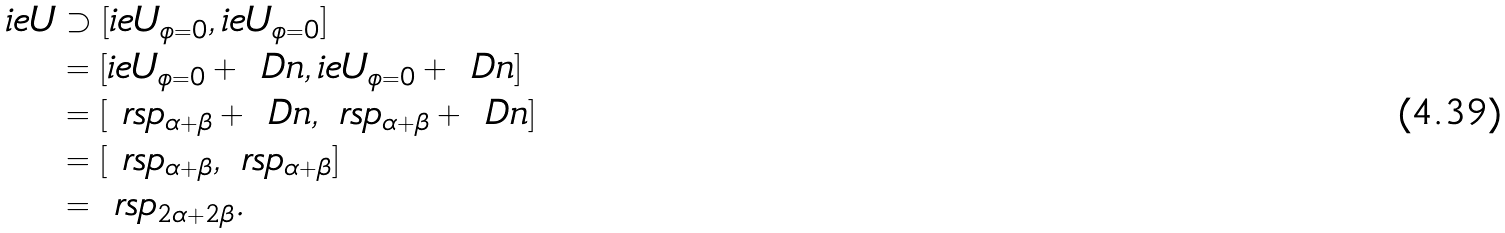Convert formula to latex. <formula><loc_0><loc_0><loc_500><loc_500>\L i e U & \supset [ \L i e U _ { \phi = 0 } , \L i e U _ { \phi = 0 } ] \\ & = [ \L i e U _ { \phi = 0 } + \ D n , \L i e U _ { \phi = 0 } + \ D n ] \\ & = [ \ r s p _ { \alpha + \beta } + \ D n , \ r s p _ { \alpha + \beta } + \ D n ] \\ & = [ \ r s p _ { \alpha + \beta } , \ r s p _ { \alpha + \beta } ] \\ & = \ r s p _ { 2 \alpha + 2 \beta } .</formula> 